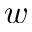Convert formula to latex. <formula><loc_0><loc_0><loc_500><loc_500>w</formula> 